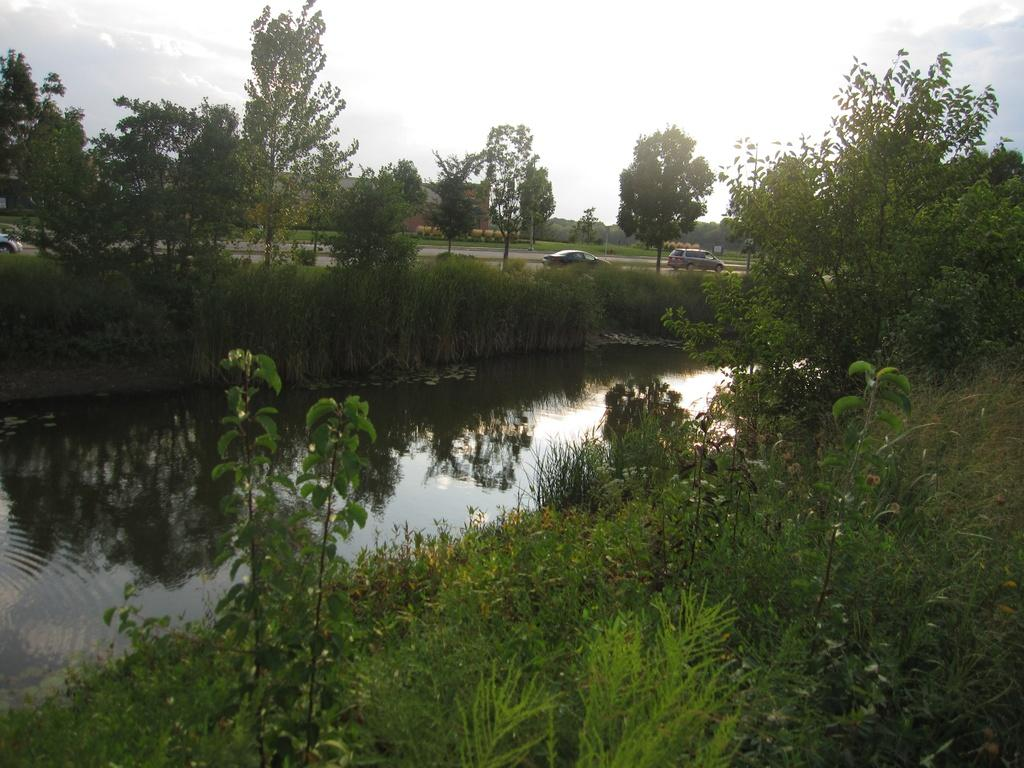What is the main feature in the middle of the image? There is a pond in the middle of the image. What can be seen near the pond? There are plants and grass beside the pond. What is visible in the background of the image? There are two cars on a road in the background of the image. What is visible at the top of the image? The sky is visible at the top of the image. Where are the clocks located in the image? There are no clocks present in the image. What type of book can be seen lying near the pond? There is no book present in the image. 